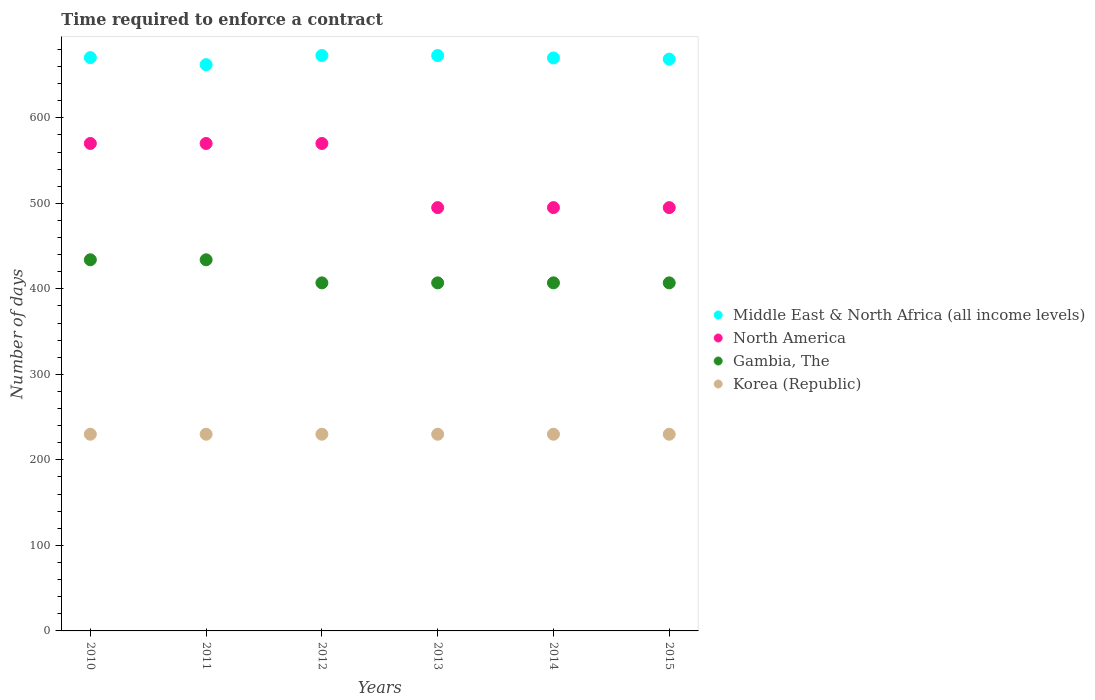What is the number of days required to enforce a contract in Korea (Republic) in 2015?
Ensure brevity in your answer.  230. Across all years, what is the maximum number of days required to enforce a contract in Korea (Republic)?
Make the answer very short. 230. Across all years, what is the minimum number of days required to enforce a contract in Gambia, The?
Provide a succinct answer. 407. What is the total number of days required to enforce a contract in Middle East & North Africa (all income levels) in the graph?
Provide a short and direct response. 4016.9. What is the difference between the number of days required to enforce a contract in North America in 2011 and that in 2014?
Your response must be concise. 75. What is the difference between the number of days required to enforce a contract in Middle East & North Africa (all income levels) in 2014 and the number of days required to enforce a contract in Korea (Republic) in 2012?
Ensure brevity in your answer.  440. What is the average number of days required to enforce a contract in Middle East & North Africa (all income levels) per year?
Your answer should be compact. 669.48. In the year 2015, what is the difference between the number of days required to enforce a contract in Korea (Republic) and number of days required to enforce a contract in North America?
Your answer should be very brief. -265. In how many years, is the number of days required to enforce a contract in Middle East & North Africa (all income levels) greater than 300 days?
Your response must be concise. 6. What is the ratio of the number of days required to enforce a contract in Gambia, The in 2010 to that in 2011?
Your answer should be very brief. 1. Is the number of days required to enforce a contract in Middle East & North Africa (all income levels) in 2010 less than that in 2013?
Your answer should be very brief. Yes. What is the difference between the highest and the second highest number of days required to enforce a contract in Gambia, The?
Offer a very short reply. 0. What is the difference between the highest and the lowest number of days required to enforce a contract in Korea (Republic)?
Provide a succinct answer. 0. Is it the case that in every year, the sum of the number of days required to enforce a contract in North America and number of days required to enforce a contract in Middle East & North Africa (all income levels)  is greater than the sum of number of days required to enforce a contract in Gambia, The and number of days required to enforce a contract in Korea (Republic)?
Keep it short and to the point. Yes. Is it the case that in every year, the sum of the number of days required to enforce a contract in Korea (Republic) and number of days required to enforce a contract in Gambia, The  is greater than the number of days required to enforce a contract in North America?
Your answer should be very brief. Yes. Is the number of days required to enforce a contract in North America strictly greater than the number of days required to enforce a contract in Middle East & North Africa (all income levels) over the years?
Your answer should be very brief. No. Is the number of days required to enforce a contract in Korea (Republic) strictly less than the number of days required to enforce a contract in Middle East & North Africa (all income levels) over the years?
Make the answer very short. Yes. How many dotlines are there?
Give a very brief answer. 4. Are the values on the major ticks of Y-axis written in scientific E-notation?
Your response must be concise. No. Does the graph contain grids?
Your answer should be very brief. No. What is the title of the graph?
Your answer should be very brief. Time required to enforce a contract. What is the label or title of the Y-axis?
Offer a very short reply. Number of days. What is the Number of days of Middle East & North Africa (all income levels) in 2010?
Provide a succinct answer. 670.42. What is the Number of days of North America in 2010?
Make the answer very short. 570. What is the Number of days in Gambia, The in 2010?
Provide a succinct answer. 434. What is the Number of days of Korea (Republic) in 2010?
Your response must be concise. 230. What is the Number of days in Middle East & North Africa (all income levels) in 2011?
Give a very brief answer. 662.15. What is the Number of days of North America in 2011?
Provide a short and direct response. 570. What is the Number of days in Gambia, The in 2011?
Keep it short and to the point. 434. What is the Number of days in Korea (Republic) in 2011?
Make the answer very short. 230. What is the Number of days of Middle East & North Africa (all income levels) in 2012?
Provide a succinct answer. 672.86. What is the Number of days of North America in 2012?
Provide a short and direct response. 570. What is the Number of days of Gambia, The in 2012?
Keep it short and to the point. 407. What is the Number of days in Korea (Republic) in 2012?
Make the answer very short. 230. What is the Number of days of Middle East & North Africa (all income levels) in 2013?
Offer a very short reply. 672.86. What is the Number of days in North America in 2013?
Ensure brevity in your answer.  495. What is the Number of days of Gambia, The in 2013?
Provide a succinct answer. 407. What is the Number of days of Korea (Republic) in 2013?
Give a very brief answer. 230. What is the Number of days in Middle East & North Africa (all income levels) in 2014?
Offer a very short reply. 670. What is the Number of days in North America in 2014?
Keep it short and to the point. 495. What is the Number of days in Gambia, The in 2014?
Ensure brevity in your answer.  407. What is the Number of days of Korea (Republic) in 2014?
Give a very brief answer. 230. What is the Number of days of Middle East & North Africa (all income levels) in 2015?
Provide a short and direct response. 668.62. What is the Number of days in North America in 2015?
Offer a very short reply. 495. What is the Number of days of Gambia, The in 2015?
Provide a succinct answer. 407. What is the Number of days of Korea (Republic) in 2015?
Give a very brief answer. 230. Across all years, what is the maximum Number of days in Middle East & North Africa (all income levels)?
Your response must be concise. 672.86. Across all years, what is the maximum Number of days in North America?
Your answer should be compact. 570. Across all years, what is the maximum Number of days in Gambia, The?
Give a very brief answer. 434. Across all years, what is the maximum Number of days of Korea (Republic)?
Ensure brevity in your answer.  230. Across all years, what is the minimum Number of days of Middle East & North Africa (all income levels)?
Ensure brevity in your answer.  662.15. Across all years, what is the minimum Number of days of North America?
Keep it short and to the point. 495. Across all years, what is the minimum Number of days in Gambia, The?
Make the answer very short. 407. Across all years, what is the minimum Number of days in Korea (Republic)?
Your answer should be compact. 230. What is the total Number of days in Middle East & North Africa (all income levels) in the graph?
Give a very brief answer. 4016.9. What is the total Number of days in North America in the graph?
Provide a short and direct response. 3195. What is the total Number of days of Gambia, The in the graph?
Your answer should be compact. 2496. What is the total Number of days of Korea (Republic) in the graph?
Your answer should be very brief. 1380. What is the difference between the Number of days in Middle East & North Africa (all income levels) in 2010 and that in 2011?
Keep it short and to the point. 8.27. What is the difference between the Number of days of Korea (Republic) in 2010 and that in 2011?
Give a very brief answer. 0. What is the difference between the Number of days of Middle East & North Africa (all income levels) in 2010 and that in 2012?
Ensure brevity in your answer.  -2.44. What is the difference between the Number of days of North America in 2010 and that in 2012?
Your response must be concise. 0. What is the difference between the Number of days of Middle East & North Africa (all income levels) in 2010 and that in 2013?
Offer a terse response. -2.44. What is the difference between the Number of days in Middle East & North Africa (all income levels) in 2010 and that in 2014?
Your answer should be compact. 0.42. What is the difference between the Number of days of North America in 2010 and that in 2014?
Give a very brief answer. 75. What is the difference between the Number of days in Middle East & North Africa (all income levels) in 2010 and that in 2015?
Keep it short and to the point. 1.8. What is the difference between the Number of days of North America in 2010 and that in 2015?
Provide a succinct answer. 75. What is the difference between the Number of days in Middle East & North Africa (all income levels) in 2011 and that in 2012?
Make the answer very short. -10.71. What is the difference between the Number of days in Korea (Republic) in 2011 and that in 2012?
Ensure brevity in your answer.  0. What is the difference between the Number of days in Middle East & North Africa (all income levels) in 2011 and that in 2013?
Make the answer very short. -10.71. What is the difference between the Number of days of North America in 2011 and that in 2013?
Your response must be concise. 75. What is the difference between the Number of days in Korea (Republic) in 2011 and that in 2013?
Offer a very short reply. 0. What is the difference between the Number of days of Middle East & North Africa (all income levels) in 2011 and that in 2014?
Make the answer very short. -7.85. What is the difference between the Number of days in North America in 2011 and that in 2014?
Keep it short and to the point. 75. What is the difference between the Number of days of Gambia, The in 2011 and that in 2014?
Offer a very short reply. 27. What is the difference between the Number of days of Middle East & North Africa (all income levels) in 2011 and that in 2015?
Give a very brief answer. -6.47. What is the difference between the Number of days in North America in 2011 and that in 2015?
Make the answer very short. 75. What is the difference between the Number of days of Gambia, The in 2011 and that in 2015?
Your response must be concise. 27. What is the difference between the Number of days of Korea (Republic) in 2011 and that in 2015?
Keep it short and to the point. 0. What is the difference between the Number of days of Gambia, The in 2012 and that in 2013?
Your answer should be compact. 0. What is the difference between the Number of days of Middle East & North Africa (all income levels) in 2012 and that in 2014?
Your answer should be compact. 2.86. What is the difference between the Number of days in North America in 2012 and that in 2014?
Your answer should be very brief. 75. What is the difference between the Number of days of Gambia, The in 2012 and that in 2014?
Provide a succinct answer. 0. What is the difference between the Number of days of Middle East & North Africa (all income levels) in 2012 and that in 2015?
Ensure brevity in your answer.  4.24. What is the difference between the Number of days of North America in 2012 and that in 2015?
Provide a succinct answer. 75. What is the difference between the Number of days in Gambia, The in 2012 and that in 2015?
Offer a terse response. 0. What is the difference between the Number of days of Middle East & North Africa (all income levels) in 2013 and that in 2014?
Your response must be concise. 2.86. What is the difference between the Number of days of North America in 2013 and that in 2014?
Offer a terse response. 0. What is the difference between the Number of days in Middle East & North Africa (all income levels) in 2013 and that in 2015?
Your answer should be compact. 4.24. What is the difference between the Number of days in Gambia, The in 2013 and that in 2015?
Provide a succinct answer. 0. What is the difference between the Number of days in Middle East & North Africa (all income levels) in 2014 and that in 2015?
Offer a very short reply. 1.38. What is the difference between the Number of days of North America in 2014 and that in 2015?
Your response must be concise. 0. What is the difference between the Number of days in Gambia, The in 2014 and that in 2015?
Provide a short and direct response. 0. What is the difference between the Number of days of Middle East & North Africa (all income levels) in 2010 and the Number of days of North America in 2011?
Give a very brief answer. 100.42. What is the difference between the Number of days of Middle East & North Africa (all income levels) in 2010 and the Number of days of Gambia, The in 2011?
Offer a terse response. 236.42. What is the difference between the Number of days of Middle East & North Africa (all income levels) in 2010 and the Number of days of Korea (Republic) in 2011?
Give a very brief answer. 440.42. What is the difference between the Number of days in North America in 2010 and the Number of days in Gambia, The in 2011?
Give a very brief answer. 136. What is the difference between the Number of days of North America in 2010 and the Number of days of Korea (Republic) in 2011?
Provide a short and direct response. 340. What is the difference between the Number of days in Gambia, The in 2010 and the Number of days in Korea (Republic) in 2011?
Ensure brevity in your answer.  204. What is the difference between the Number of days in Middle East & North Africa (all income levels) in 2010 and the Number of days in North America in 2012?
Offer a very short reply. 100.42. What is the difference between the Number of days of Middle East & North Africa (all income levels) in 2010 and the Number of days of Gambia, The in 2012?
Ensure brevity in your answer.  263.42. What is the difference between the Number of days in Middle East & North Africa (all income levels) in 2010 and the Number of days in Korea (Republic) in 2012?
Provide a succinct answer. 440.42. What is the difference between the Number of days of North America in 2010 and the Number of days of Gambia, The in 2012?
Provide a succinct answer. 163. What is the difference between the Number of days of North America in 2010 and the Number of days of Korea (Republic) in 2012?
Give a very brief answer. 340. What is the difference between the Number of days in Gambia, The in 2010 and the Number of days in Korea (Republic) in 2012?
Keep it short and to the point. 204. What is the difference between the Number of days in Middle East & North Africa (all income levels) in 2010 and the Number of days in North America in 2013?
Provide a succinct answer. 175.42. What is the difference between the Number of days of Middle East & North Africa (all income levels) in 2010 and the Number of days of Gambia, The in 2013?
Ensure brevity in your answer.  263.42. What is the difference between the Number of days of Middle East & North Africa (all income levels) in 2010 and the Number of days of Korea (Republic) in 2013?
Provide a short and direct response. 440.42. What is the difference between the Number of days in North America in 2010 and the Number of days in Gambia, The in 2013?
Keep it short and to the point. 163. What is the difference between the Number of days of North America in 2010 and the Number of days of Korea (Republic) in 2013?
Give a very brief answer. 340. What is the difference between the Number of days of Gambia, The in 2010 and the Number of days of Korea (Republic) in 2013?
Offer a terse response. 204. What is the difference between the Number of days of Middle East & North Africa (all income levels) in 2010 and the Number of days of North America in 2014?
Ensure brevity in your answer.  175.42. What is the difference between the Number of days of Middle East & North Africa (all income levels) in 2010 and the Number of days of Gambia, The in 2014?
Your answer should be compact. 263.42. What is the difference between the Number of days of Middle East & North Africa (all income levels) in 2010 and the Number of days of Korea (Republic) in 2014?
Ensure brevity in your answer.  440.42. What is the difference between the Number of days of North America in 2010 and the Number of days of Gambia, The in 2014?
Give a very brief answer. 163. What is the difference between the Number of days of North America in 2010 and the Number of days of Korea (Republic) in 2014?
Ensure brevity in your answer.  340. What is the difference between the Number of days in Gambia, The in 2010 and the Number of days in Korea (Republic) in 2014?
Provide a succinct answer. 204. What is the difference between the Number of days in Middle East & North Africa (all income levels) in 2010 and the Number of days in North America in 2015?
Make the answer very short. 175.42. What is the difference between the Number of days in Middle East & North Africa (all income levels) in 2010 and the Number of days in Gambia, The in 2015?
Give a very brief answer. 263.42. What is the difference between the Number of days of Middle East & North Africa (all income levels) in 2010 and the Number of days of Korea (Republic) in 2015?
Your answer should be compact. 440.42. What is the difference between the Number of days in North America in 2010 and the Number of days in Gambia, The in 2015?
Keep it short and to the point. 163. What is the difference between the Number of days in North America in 2010 and the Number of days in Korea (Republic) in 2015?
Keep it short and to the point. 340. What is the difference between the Number of days of Gambia, The in 2010 and the Number of days of Korea (Republic) in 2015?
Your answer should be very brief. 204. What is the difference between the Number of days of Middle East & North Africa (all income levels) in 2011 and the Number of days of North America in 2012?
Your response must be concise. 92.15. What is the difference between the Number of days of Middle East & North Africa (all income levels) in 2011 and the Number of days of Gambia, The in 2012?
Keep it short and to the point. 255.15. What is the difference between the Number of days in Middle East & North Africa (all income levels) in 2011 and the Number of days in Korea (Republic) in 2012?
Keep it short and to the point. 432.15. What is the difference between the Number of days in North America in 2011 and the Number of days in Gambia, The in 2012?
Your answer should be very brief. 163. What is the difference between the Number of days in North America in 2011 and the Number of days in Korea (Republic) in 2012?
Offer a terse response. 340. What is the difference between the Number of days of Gambia, The in 2011 and the Number of days of Korea (Republic) in 2012?
Your response must be concise. 204. What is the difference between the Number of days in Middle East & North Africa (all income levels) in 2011 and the Number of days in North America in 2013?
Ensure brevity in your answer.  167.15. What is the difference between the Number of days in Middle East & North Africa (all income levels) in 2011 and the Number of days in Gambia, The in 2013?
Your response must be concise. 255.15. What is the difference between the Number of days in Middle East & North Africa (all income levels) in 2011 and the Number of days in Korea (Republic) in 2013?
Provide a succinct answer. 432.15. What is the difference between the Number of days in North America in 2011 and the Number of days in Gambia, The in 2013?
Provide a succinct answer. 163. What is the difference between the Number of days in North America in 2011 and the Number of days in Korea (Republic) in 2013?
Offer a very short reply. 340. What is the difference between the Number of days of Gambia, The in 2011 and the Number of days of Korea (Republic) in 2013?
Make the answer very short. 204. What is the difference between the Number of days in Middle East & North Africa (all income levels) in 2011 and the Number of days in North America in 2014?
Make the answer very short. 167.15. What is the difference between the Number of days of Middle East & North Africa (all income levels) in 2011 and the Number of days of Gambia, The in 2014?
Offer a very short reply. 255.15. What is the difference between the Number of days of Middle East & North Africa (all income levels) in 2011 and the Number of days of Korea (Republic) in 2014?
Offer a terse response. 432.15. What is the difference between the Number of days in North America in 2011 and the Number of days in Gambia, The in 2014?
Ensure brevity in your answer.  163. What is the difference between the Number of days of North America in 2011 and the Number of days of Korea (Republic) in 2014?
Make the answer very short. 340. What is the difference between the Number of days in Gambia, The in 2011 and the Number of days in Korea (Republic) in 2014?
Provide a short and direct response. 204. What is the difference between the Number of days in Middle East & North Africa (all income levels) in 2011 and the Number of days in North America in 2015?
Provide a short and direct response. 167.15. What is the difference between the Number of days in Middle East & North Africa (all income levels) in 2011 and the Number of days in Gambia, The in 2015?
Offer a very short reply. 255.15. What is the difference between the Number of days in Middle East & North Africa (all income levels) in 2011 and the Number of days in Korea (Republic) in 2015?
Give a very brief answer. 432.15. What is the difference between the Number of days of North America in 2011 and the Number of days of Gambia, The in 2015?
Offer a terse response. 163. What is the difference between the Number of days of North America in 2011 and the Number of days of Korea (Republic) in 2015?
Your answer should be compact. 340. What is the difference between the Number of days in Gambia, The in 2011 and the Number of days in Korea (Republic) in 2015?
Make the answer very short. 204. What is the difference between the Number of days of Middle East & North Africa (all income levels) in 2012 and the Number of days of North America in 2013?
Your answer should be compact. 177.86. What is the difference between the Number of days of Middle East & North Africa (all income levels) in 2012 and the Number of days of Gambia, The in 2013?
Your answer should be compact. 265.86. What is the difference between the Number of days of Middle East & North Africa (all income levels) in 2012 and the Number of days of Korea (Republic) in 2013?
Provide a short and direct response. 442.86. What is the difference between the Number of days of North America in 2012 and the Number of days of Gambia, The in 2013?
Offer a very short reply. 163. What is the difference between the Number of days of North America in 2012 and the Number of days of Korea (Republic) in 2013?
Keep it short and to the point. 340. What is the difference between the Number of days in Gambia, The in 2012 and the Number of days in Korea (Republic) in 2013?
Your response must be concise. 177. What is the difference between the Number of days in Middle East & North Africa (all income levels) in 2012 and the Number of days in North America in 2014?
Offer a terse response. 177.86. What is the difference between the Number of days in Middle East & North Africa (all income levels) in 2012 and the Number of days in Gambia, The in 2014?
Your answer should be very brief. 265.86. What is the difference between the Number of days of Middle East & North Africa (all income levels) in 2012 and the Number of days of Korea (Republic) in 2014?
Provide a short and direct response. 442.86. What is the difference between the Number of days of North America in 2012 and the Number of days of Gambia, The in 2014?
Keep it short and to the point. 163. What is the difference between the Number of days in North America in 2012 and the Number of days in Korea (Republic) in 2014?
Provide a succinct answer. 340. What is the difference between the Number of days in Gambia, The in 2012 and the Number of days in Korea (Republic) in 2014?
Your answer should be very brief. 177. What is the difference between the Number of days in Middle East & North Africa (all income levels) in 2012 and the Number of days in North America in 2015?
Keep it short and to the point. 177.86. What is the difference between the Number of days in Middle East & North Africa (all income levels) in 2012 and the Number of days in Gambia, The in 2015?
Give a very brief answer. 265.86. What is the difference between the Number of days of Middle East & North Africa (all income levels) in 2012 and the Number of days of Korea (Republic) in 2015?
Your response must be concise. 442.86. What is the difference between the Number of days in North America in 2012 and the Number of days in Gambia, The in 2015?
Keep it short and to the point. 163. What is the difference between the Number of days in North America in 2012 and the Number of days in Korea (Republic) in 2015?
Keep it short and to the point. 340. What is the difference between the Number of days in Gambia, The in 2012 and the Number of days in Korea (Republic) in 2015?
Make the answer very short. 177. What is the difference between the Number of days of Middle East & North Africa (all income levels) in 2013 and the Number of days of North America in 2014?
Ensure brevity in your answer.  177.86. What is the difference between the Number of days in Middle East & North Africa (all income levels) in 2013 and the Number of days in Gambia, The in 2014?
Your answer should be very brief. 265.86. What is the difference between the Number of days of Middle East & North Africa (all income levels) in 2013 and the Number of days of Korea (Republic) in 2014?
Provide a short and direct response. 442.86. What is the difference between the Number of days of North America in 2013 and the Number of days of Korea (Republic) in 2014?
Provide a succinct answer. 265. What is the difference between the Number of days of Gambia, The in 2013 and the Number of days of Korea (Republic) in 2014?
Make the answer very short. 177. What is the difference between the Number of days in Middle East & North Africa (all income levels) in 2013 and the Number of days in North America in 2015?
Offer a very short reply. 177.86. What is the difference between the Number of days of Middle East & North Africa (all income levels) in 2013 and the Number of days of Gambia, The in 2015?
Your response must be concise. 265.86. What is the difference between the Number of days in Middle East & North Africa (all income levels) in 2013 and the Number of days in Korea (Republic) in 2015?
Ensure brevity in your answer.  442.86. What is the difference between the Number of days of North America in 2013 and the Number of days of Gambia, The in 2015?
Keep it short and to the point. 88. What is the difference between the Number of days in North America in 2013 and the Number of days in Korea (Republic) in 2015?
Keep it short and to the point. 265. What is the difference between the Number of days in Gambia, The in 2013 and the Number of days in Korea (Republic) in 2015?
Offer a very short reply. 177. What is the difference between the Number of days in Middle East & North Africa (all income levels) in 2014 and the Number of days in North America in 2015?
Offer a terse response. 175. What is the difference between the Number of days of Middle East & North Africa (all income levels) in 2014 and the Number of days of Gambia, The in 2015?
Make the answer very short. 263. What is the difference between the Number of days in Middle East & North Africa (all income levels) in 2014 and the Number of days in Korea (Republic) in 2015?
Offer a very short reply. 440. What is the difference between the Number of days of North America in 2014 and the Number of days of Korea (Republic) in 2015?
Ensure brevity in your answer.  265. What is the difference between the Number of days in Gambia, The in 2014 and the Number of days in Korea (Republic) in 2015?
Ensure brevity in your answer.  177. What is the average Number of days of Middle East & North Africa (all income levels) per year?
Make the answer very short. 669.48. What is the average Number of days of North America per year?
Give a very brief answer. 532.5. What is the average Number of days in Gambia, The per year?
Provide a succinct answer. 416. What is the average Number of days in Korea (Republic) per year?
Keep it short and to the point. 230. In the year 2010, what is the difference between the Number of days of Middle East & North Africa (all income levels) and Number of days of North America?
Ensure brevity in your answer.  100.42. In the year 2010, what is the difference between the Number of days in Middle East & North Africa (all income levels) and Number of days in Gambia, The?
Offer a terse response. 236.42. In the year 2010, what is the difference between the Number of days of Middle East & North Africa (all income levels) and Number of days of Korea (Republic)?
Provide a short and direct response. 440.42. In the year 2010, what is the difference between the Number of days of North America and Number of days of Gambia, The?
Ensure brevity in your answer.  136. In the year 2010, what is the difference between the Number of days of North America and Number of days of Korea (Republic)?
Your answer should be compact. 340. In the year 2010, what is the difference between the Number of days in Gambia, The and Number of days in Korea (Republic)?
Give a very brief answer. 204. In the year 2011, what is the difference between the Number of days in Middle East & North Africa (all income levels) and Number of days in North America?
Offer a very short reply. 92.15. In the year 2011, what is the difference between the Number of days of Middle East & North Africa (all income levels) and Number of days of Gambia, The?
Provide a succinct answer. 228.15. In the year 2011, what is the difference between the Number of days in Middle East & North Africa (all income levels) and Number of days in Korea (Republic)?
Your response must be concise. 432.15. In the year 2011, what is the difference between the Number of days of North America and Number of days of Gambia, The?
Offer a terse response. 136. In the year 2011, what is the difference between the Number of days in North America and Number of days in Korea (Republic)?
Make the answer very short. 340. In the year 2011, what is the difference between the Number of days in Gambia, The and Number of days in Korea (Republic)?
Provide a short and direct response. 204. In the year 2012, what is the difference between the Number of days of Middle East & North Africa (all income levels) and Number of days of North America?
Your answer should be compact. 102.86. In the year 2012, what is the difference between the Number of days in Middle East & North Africa (all income levels) and Number of days in Gambia, The?
Offer a terse response. 265.86. In the year 2012, what is the difference between the Number of days in Middle East & North Africa (all income levels) and Number of days in Korea (Republic)?
Ensure brevity in your answer.  442.86. In the year 2012, what is the difference between the Number of days in North America and Number of days in Gambia, The?
Provide a succinct answer. 163. In the year 2012, what is the difference between the Number of days in North America and Number of days in Korea (Republic)?
Your response must be concise. 340. In the year 2012, what is the difference between the Number of days of Gambia, The and Number of days of Korea (Republic)?
Give a very brief answer. 177. In the year 2013, what is the difference between the Number of days of Middle East & North Africa (all income levels) and Number of days of North America?
Your response must be concise. 177.86. In the year 2013, what is the difference between the Number of days of Middle East & North Africa (all income levels) and Number of days of Gambia, The?
Keep it short and to the point. 265.86. In the year 2013, what is the difference between the Number of days of Middle East & North Africa (all income levels) and Number of days of Korea (Republic)?
Your response must be concise. 442.86. In the year 2013, what is the difference between the Number of days of North America and Number of days of Korea (Republic)?
Keep it short and to the point. 265. In the year 2013, what is the difference between the Number of days of Gambia, The and Number of days of Korea (Republic)?
Make the answer very short. 177. In the year 2014, what is the difference between the Number of days in Middle East & North Africa (all income levels) and Number of days in North America?
Offer a terse response. 175. In the year 2014, what is the difference between the Number of days of Middle East & North Africa (all income levels) and Number of days of Gambia, The?
Keep it short and to the point. 263. In the year 2014, what is the difference between the Number of days of Middle East & North Africa (all income levels) and Number of days of Korea (Republic)?
Offer a very short reply. 440. In the year 2014, what is the difference between the Number of days in North America and Number of days in Gambia, The?
Give a very brief answer. 88. In the year 2014, what is the difference between the Number of days of North America and Number of days of Korea (Republic)?
Offer a terse response. 265. In the year 2014, what is the difference between the Number of days in Gambia, The and Number of days in Korea (Republic)?
Provide a short and direct response. 177. In the year 2015, what is the difference between the Number of days of Middle East & North Africa (all income levels) and Number of days of North America?
Your answer should be very brief. 173.62. In the year 2015, what is the difference between the Number of days of Middle East & North Africa (all income levels) and Number of days of Gambia, The?
Keep it short and to the point. 261.62. In the year 2015, what is the difference between the Number of days in Middle East & North Africa (all income levels) and Number of days in Korea (Republic)?
Ensure brevity in your answer.  438.62. In the year 2015, what is the difference between the Number of days in North America and Number of days in Korea (Republic)?
Offer a terse response. 265. In the year 2015, what is the difference between the Number of days of Gambia, The and Number of days of Korea (Republic)?
Offer a terse response. 177. What is the ratio of the Number of days of Middle East & North Africa (all income levels) in 2010 to that in 2011?
Your answer should be very brief. 1.01. What is the ratio of the Number of days of North America in 2010 to that in 2011?
Keep it short and to the point. 1. What is the ratio of the Number of days in Gambia, The in 2010 to that in 2012?
Provide a succinct answer. 1.07. What is the ratio of the Number of days in North America in 2010 to that in 2013?
Keep it short and to the point. 1.15. What is the ratio of the Number of days in Gambia, The in 2010 to that in 2013?
Keep it short and to the point. 1.07. What is the ratio of the Number of days of Korea (Republic) in 2010 to that in 2013?
Your response must be concise. 1. What is the ratio of the Number of days of Middle East & North Africa (all income levels) in 2010 to that in 2014?
Keep it short and to the point. 1. What is the ratio of the Number of days in North America in 2010 to that in 2014?
Offer a terse response. 1.15. What is the ratio of the Number of days of Gambia, The in 2010 to that in 2014?
Provide a succinct answer. 1.07. What is the ratio of the Number of days of North America in 2010 to that in 2015?
Your answer should be very brief. 1.15. What is the ratio of the Number of days in Gambia, The in 2010 to that in 2015?
Ensure brevity in your answer.  1.07. What is the ratio of the Number of days in Korea (Republic) in 2010 to that in 2015?
Make the answer very short. 1. What is the ratio of the Number of days of Middle East & North Africa (all income levels) in 2011 to that in 2012?
Keep it short and to the point. 0.98. What is the ratio of the Number of days in Gambia, The in 2011 to that in 2012?
Your answer should be very brief. 1.07. What is the ratio of the Number of days in Middle East & North Africa (all income levels) in 2011 to that in 2013?
Offer a terse response. 0.98. What is the ratio of the Number of days of North America in 2011 to that in 2013?
Give a very brief answer. 1.15. What is the ratio of the Number of days in Gambia, The in 2011 to that in 2013?
Your answer should be very brief. 1.07. What is the ratio of the Number of days in Middle East & North Africa (all income levels) in 2011 to that in 2014?
Your answer should be very brief. 0.99. What is the ratio of the Number of days in North America in 2011 to that in 2014?
Give a very brief answer. 1.15. What is the ratio of the Number of days of Gambia, The in 2011 to that in 2014?
Your answer should be very brief. 1.07. What is the ratio of the Number of days in Korea (Republic) in 2011 to that in 2014?
Offer a terse response. 1. What is the ratio of the Number of days in Middle East & North Africa (all income levels) in 2011 to that in 2015?
Ensure brevity in your answer.  0.99. What is the ratio of the Number of days in North America in 2011 to that in 2015?
Keep it short and to the point. 1.15. What is the ratio of the Number of days of Gambia, The in 2011 to that in 2015?
Offer a very short reply. 1.07. What is the ratio of the Number of days in Korea (Republic) in 2011 to that in 2015?
Ensure brevity in your answer.  1. What is the ratio of the Number of days in Middle East & North Africa (all income levels) in 2012 to that in 2013?
Provide a short and direct response. 1. What is the ratio of the Number of days of North America in 2012 to that in 2013?
Offer a very short reply. 1.15. What is the ratio of the Number of days in Gambia, The in 2012 to that in 2013?
Offer a very short reply. 1. What is the ratio of the Number of days in Korea (Republic) in 2012 to that in 2013?
Offer a terse response. 1. What is the ratio of the Number of days in North America in 2012 to that in 2014?
Provide a succinct answer. 1.15. What is the ratio of the Number of days in Korea (Republic) in 2012 to that in 2014?
Your answer should be compact. 1. What is the ratio of the Number of days of Middle East & North Africa (all income levels) in 2012 to that in 2015?
Offer a very short reply. 1.01. What is the ratio of the Number of days in North America in 2012 to that in 2015?
Your response must be concise. 1.15. What is the ratio of the Number of days in Korea (Republic) in 2012 to that in 2015?
Offer a terse response. 1. What is the ratio of the Number of days of Middle East & North Africa (all income levels) in 2013 to that in 2014?
Provide a short and direct response. 1. What is the ratio of the Number of days in Korea (Republic) in 2013 to that in 2014?
Ensure brevity in your answer.  1. What is the ratio of the Number of days in Korea (Republic) in 2013 to that in 2015?
Provide a succinct answer. 1. What is the ratio of the Number of days of Middle East & North Africa (all income levels) in 2014 to that in 2015?
Provide a succinct answer. 1. What is the ratio of the Number of days of North America in 2014 to that in 2015?
Give a very brief answer. 1. What is the ratio of the Number of days in Korea (Republic) in 2014 to that in 2015?
Your answer should be very brief. 1. What is the difference between the highest and the second highest Number of days in Middle East & North Africa (all income levels)?
Ensure brevity in your answer.  0. What is the difference between the highest and the second highest Number of days in Gambia, The?
Make the answer very short. 0. What is the difference between the highest and the second highest Number of days in Korea (Republic)?
Give a very brief answer. 0. What is the difference between the highest and the lowest Number of days in Middle East & North Africa (all income levels)?
Offer a terse response. 10.71. What is the difference between the highest and the lowest Number of days in Gambia, The?
Your answer should be very brief. 27. 